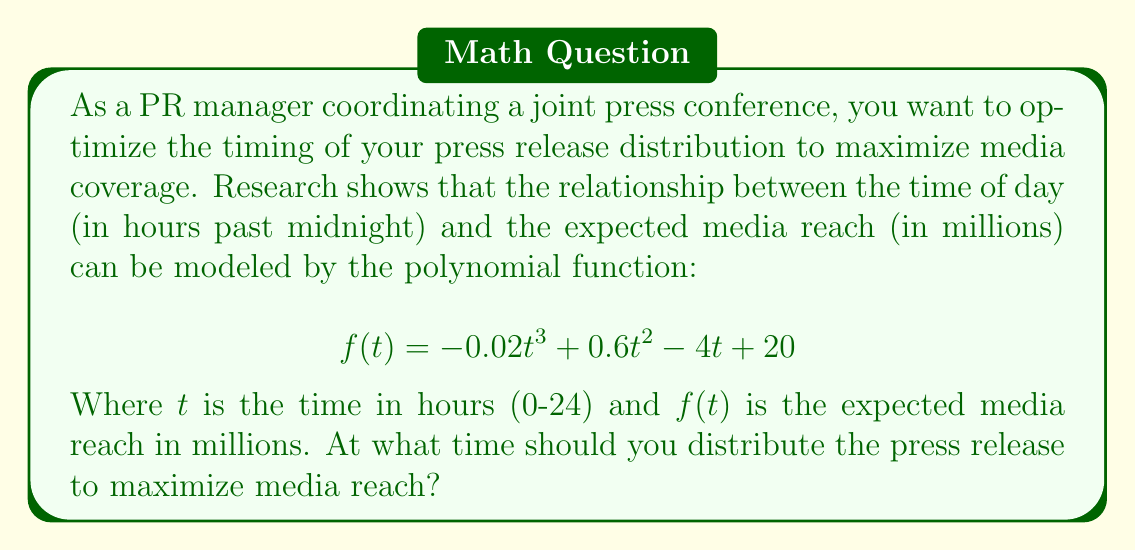Can you solve this math problem? To find the optimal time for press release distribution, we need to find the maximum value of the given polynomial function. This can be done by following these steps:

1. Find the derivative of the function:
   $$f'(t) = -0.06t^2 + 1.2t - 4$$

2. Set the derivative equal to zero to find critical points:
   $$-0.06t^2 + 1.2t - 4 = 0$$

3. Solve the quadratic equation:
   $$-0.06(t^2 - 20t + 66.67) = 0$$
   $$t^2 - 20t + 66.67 = 0$$
   Using the quadratic formula: $t = \frac{-b \pm \sqrt{b^2 - 4ac}}{2a}$
   $$t = \frac{20 \pm \sqrt{400 - 4(1)(66.67)}}{2(1)}$$
   $$t = \frac{20 \pm \sqrt{133.32}}{2}$$
   $$t \approx 16.78 \text{ or } 3.22$$

4. The second derivative is:
   $$f''(t) = -0.12t + 1.2$$

5. Evaluate the second derivative at both critical points:
   At $t = 16.78$: $f''(16.78) \approx -0.81 < 0$ (local maximum)
   At $t = 3.22$: $f''(3.22) \approx 0.81 > 0$ (local minimum)

6. The maximum occurs at $t \approx 16.78$ hours past midnight, which is approximately 4:47 PM.
Answer: 4:47 PM 